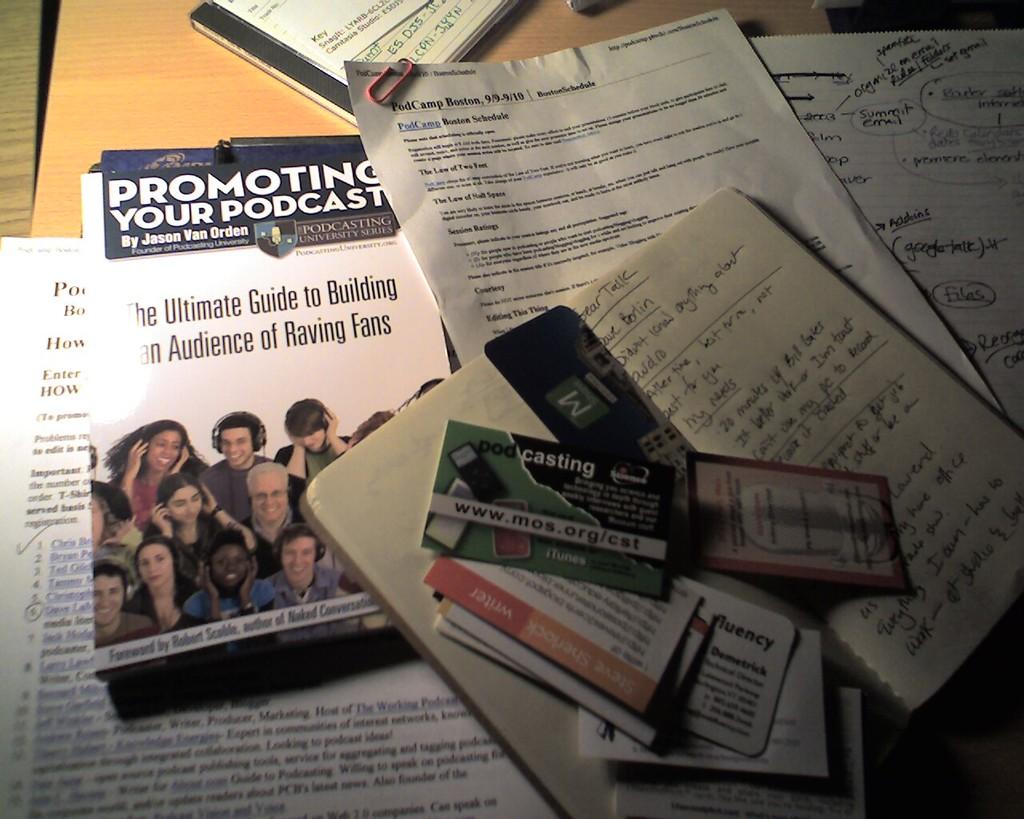What are they want you to promote?
Your answer should be very brief. Your podcast. 